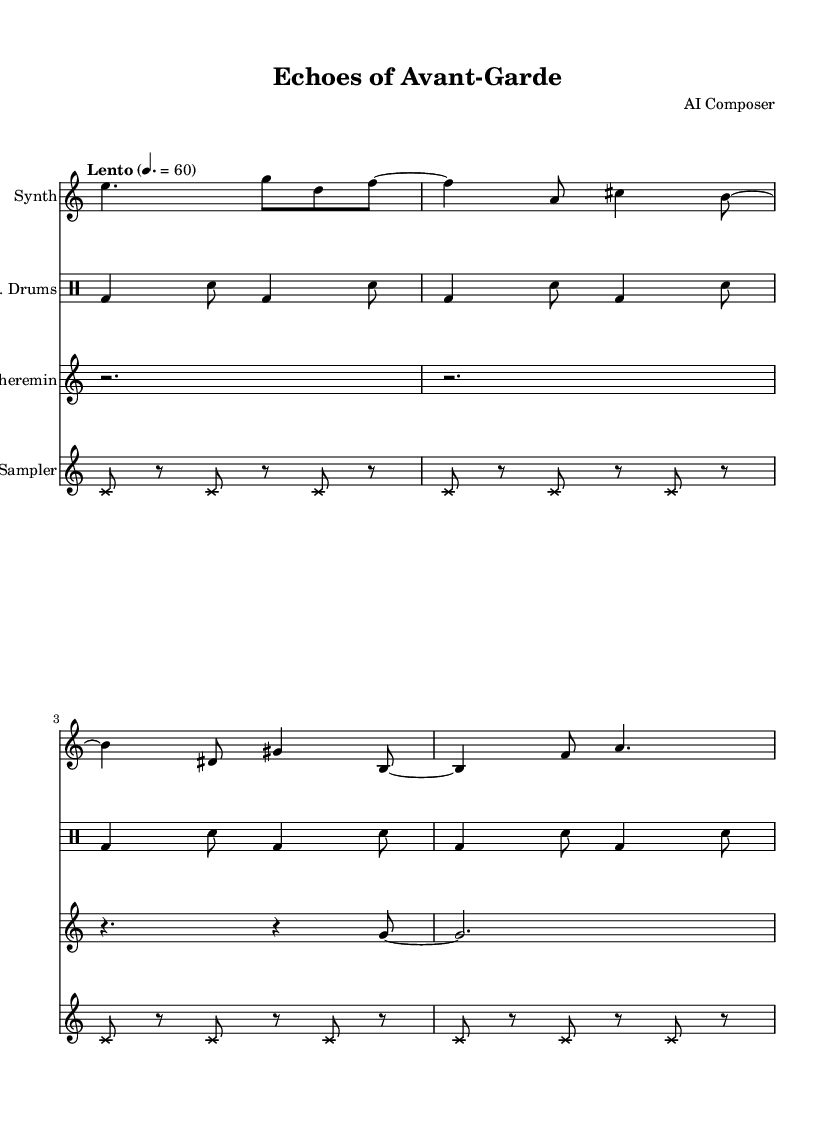What is the time signature of this music? The time signature is indicated at the beginning of the score. It shows 6 over 8, meaning there are six eighth notes in each measure.
Answer: 6/8 What is the tempo marking for this piece? The tempo marking is found above the staff, indicating a slow tempo of Lento, which corresponds to a quarter note value of 60.
Answer: Lento, 60 How many instruments are featured in this score? By counting the distinct staffs in the score, there are four: Synth, Electronic Drums, Theremin, and Sampler, indicating four different instruments.
Answer: 4 Which instrument uses a cross note head style? The Sampler is specified to use a cross note head style in its notation, which is denoted in the code.
Answer: Sampler What type of rhythm pattern do the electronic drums use? Analyzing the drum part indicates a repetitive pattern of bass drum and snare, alternating throughout the score, following a consistent rhythm structure.
Answer: Alternating bass and snare Which instrument has rests and long notes in its part? The Theremin part shows distinctive long rests followed by long notes, making it notable for having sustained tones rather than rhythmic variations.
Answer: Theremin What is the dynamic feel implied in this piece? The implied dynamic is soft and atmospheric, as indicated by the Lento tempo marking and the overall structure aimed to complement avant-garde performance art.
Answer: Soft 